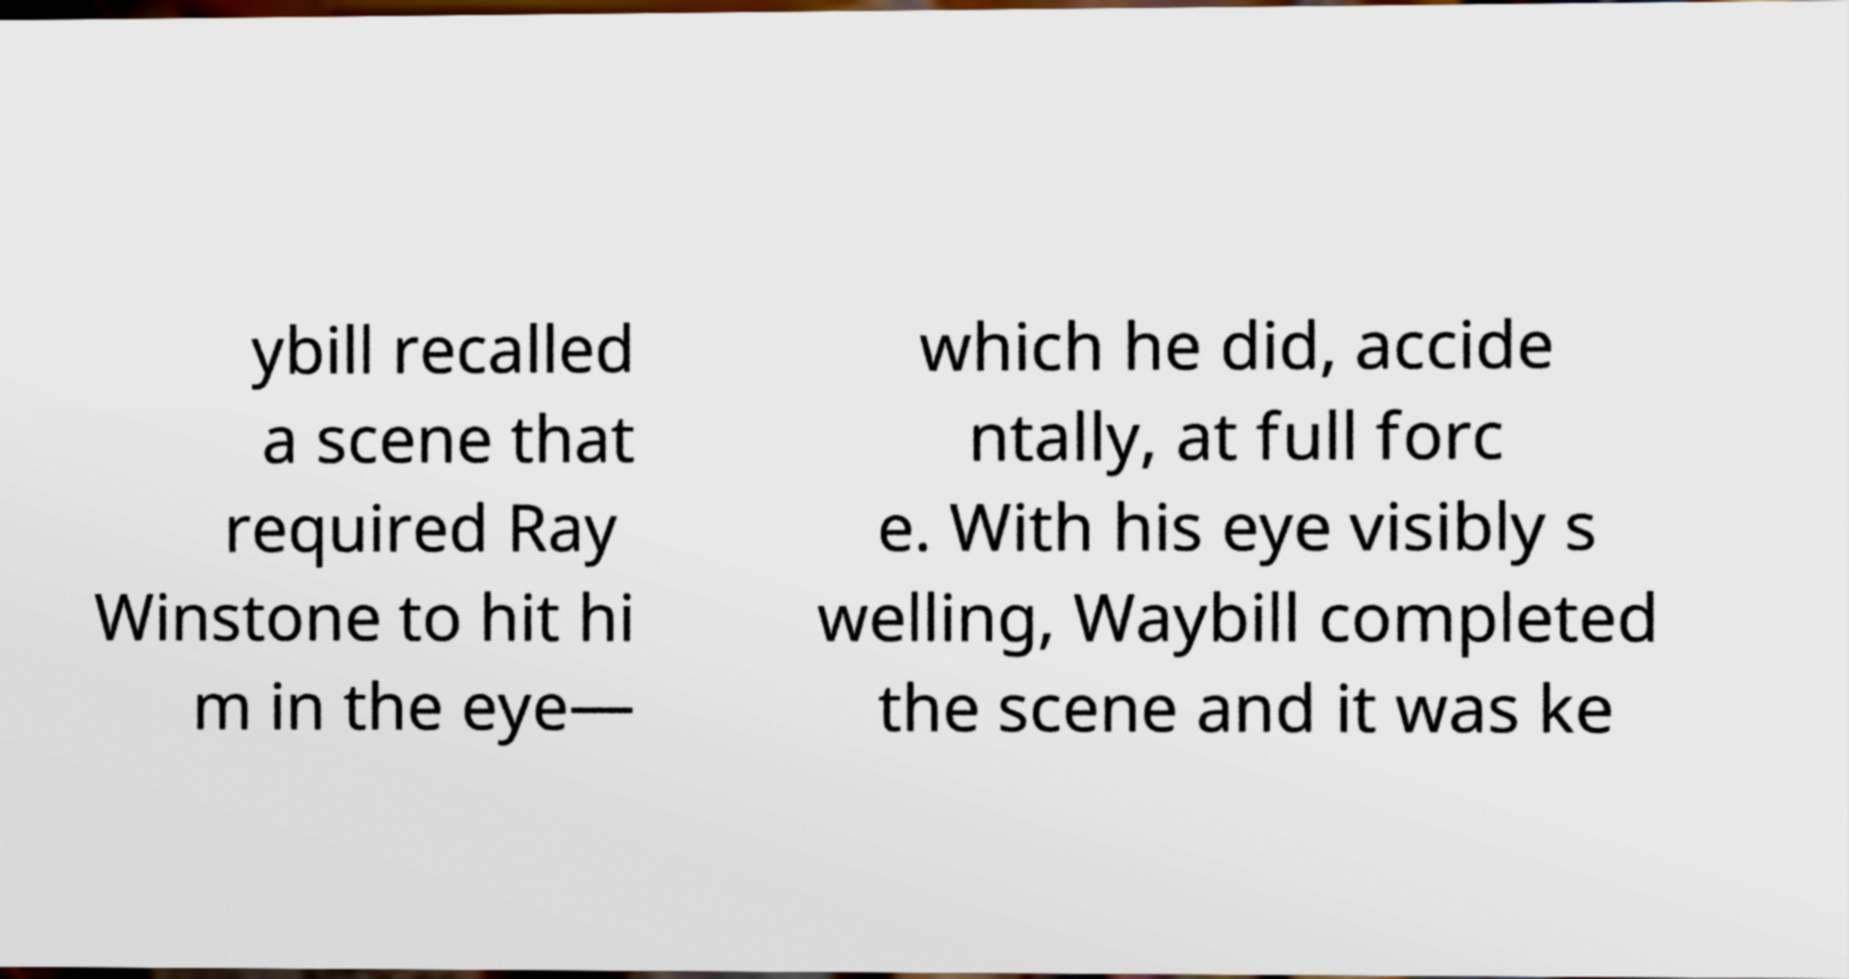Could you extract and type out the text from this image? ybill recalled a scene that required Ray Winstone to hit hi m in the eye— which he did, accide ntally, at full forc e. With his eye visibly s welling, Waybill completed the scene and it was ke 